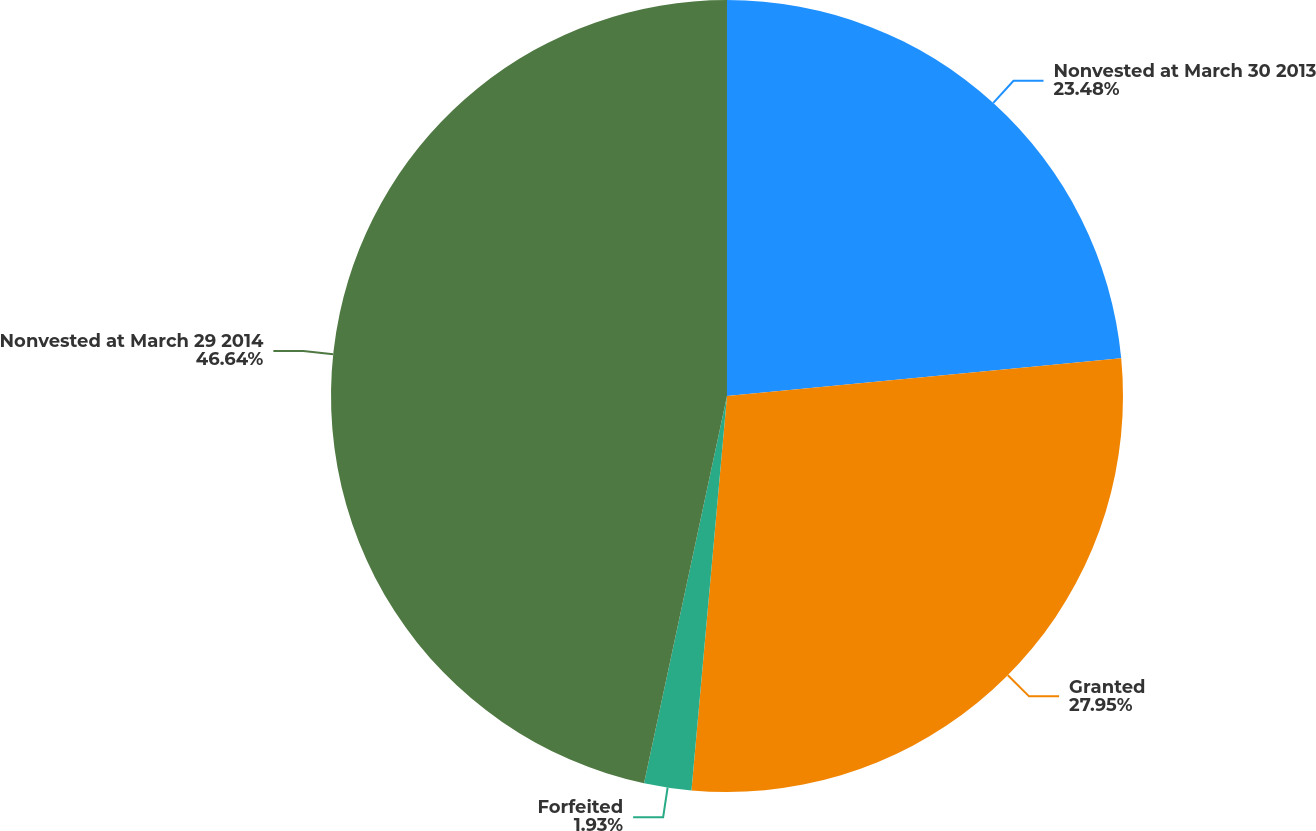Convert chart to OTSL. <chart><loc_0><loc_0><loc_500><loc_500><pie_chart><fcel>Nonvested at March 30 2013<fcel>Granted<fcel>Forfeited<fcel>Nonvested at March 29 2014<nl><fcel>23.48%<fcel>27.95%<fcel>1.93%<fcel>46.64%<nl></chart> 